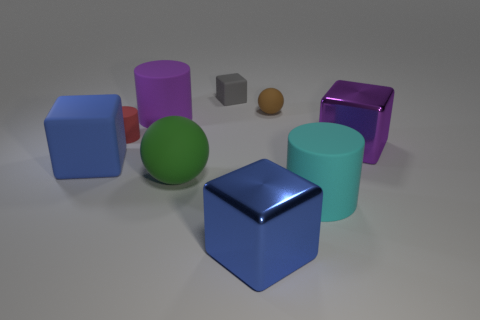What is the color of the tiny matte object that is the same shape as the large green object? The tiny object that shares its cylindrical shape with the large green one is colored gray. Its matte finish distinguishes it from the shinier surfaces of the other objects in the image. 